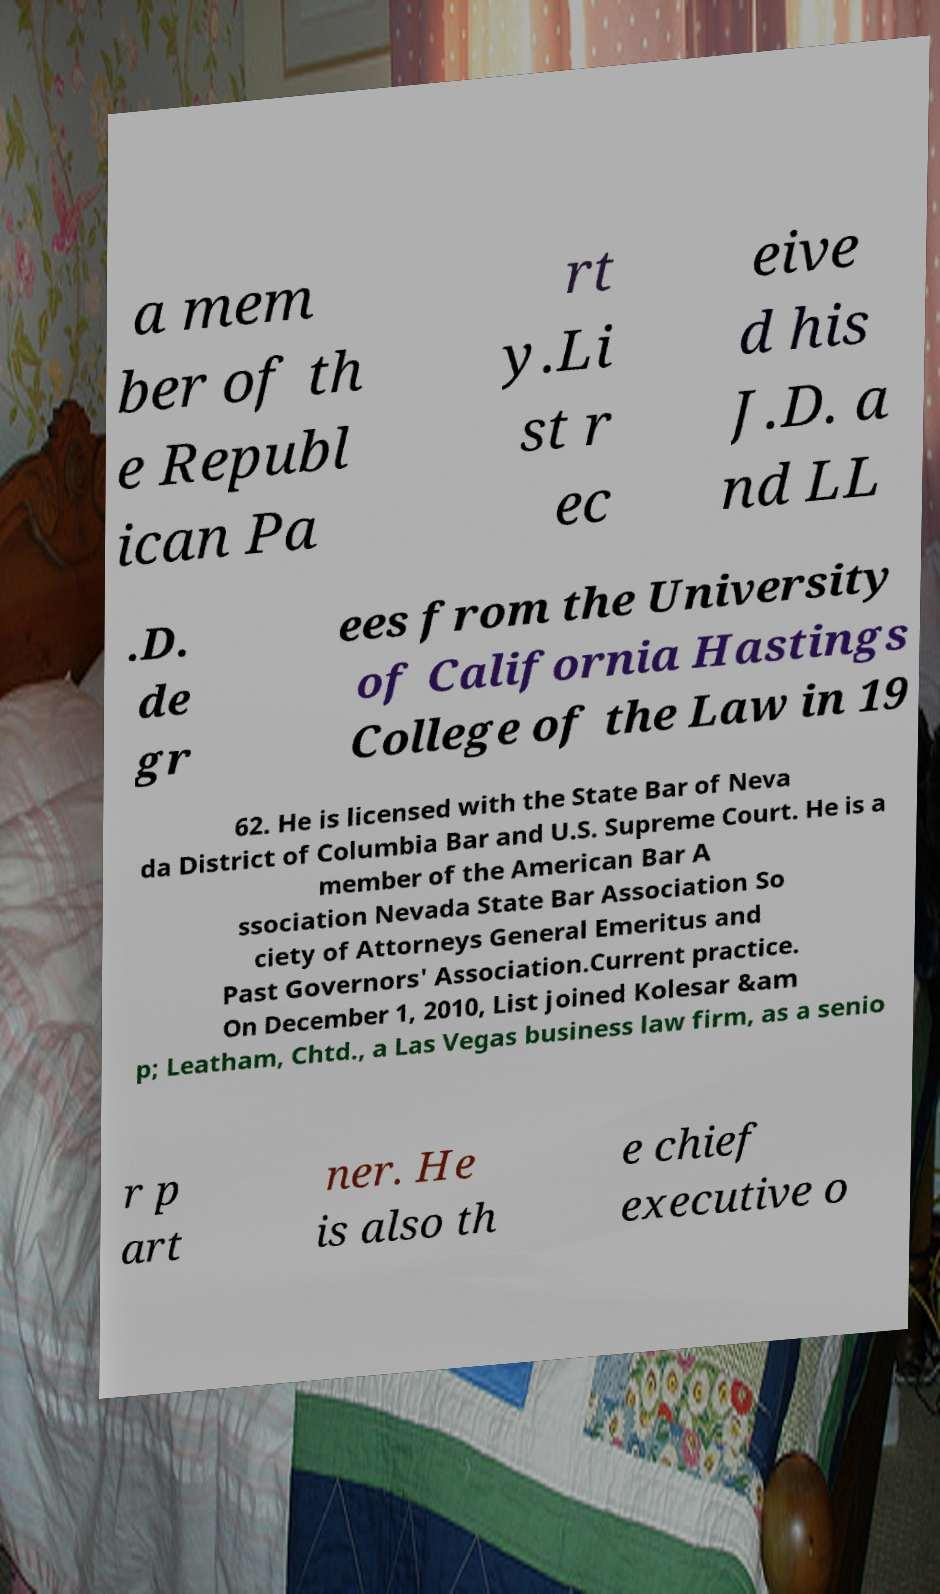There's text embedded in this image that I need extracted. Can you transcribe it verbatim? a mem ber of th e Republ ican Pa rt y.Li st r ec eive d his J.D. a nd LL .D. de gr ees from the University of California Hastings College of the Law in 19 62. He is licensed with the State Bar of Neva da District of Columbia Bar and U.S. Supreme Court. He is a member of the American Bar A ssociation Nevada State Bar Association So ciety of Attorneys General Emeritus and Past Governors' Association.Current practice. On December 1, 2010, List joined Kolesar &am p; Leatham, Chtd., a Las Vegas business law firm, as a senio r p art ner. He is also th e chief executive o 